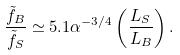<formula> <loc_0><loc_0><loc_500><loc_500>\frac { \tilde { f } _ { B } } { \tilde { f } _ { S } } \simeq 5 . 1 \alpha ^ { - 3 / 4 } \left ( \frac { L _ { S } } { L _ { B } } \right ) .</formula> 